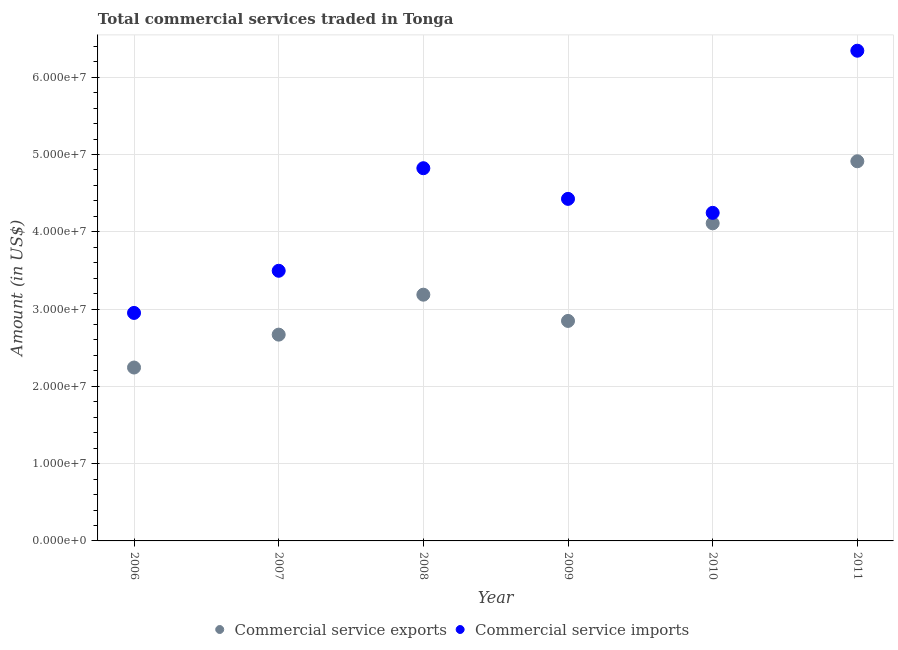How many different coloured dotlines are there?
Your answer should be compact. 2. Is the number of dotlines equal to the number of legend labels?
Ensure brevity in your answer.  Yes. What is the amount of commercial service exports in 2009?
Give a very brief answer. 2.85e+07. Across all years, what is the maximum amount of commercial service exports?
Keep it short and to the point. 4.91e+07. Across all years, what is the minimum amount of commercial service imports?
Your response must be concise. 2.95e+07. In which year was the amount of commercial service exports minimum?
Your answer should be compact. 2006. What is the total amount of commercial service exports in the graph?
Give a very brief answer. 2.00e+08. What is the difference between the amount of commercial service exports in 2009 and that in 2010?
Give a very brief answer. -1.26e+07. What is the difference between the amount of commercial service imports in 2011 and the amount of commercial service exports in 2007?
Offer a terse response. 3.67e+07. What is the average amount of commercial service imports per year?
Offer a terse response. 4.38e+07. In the year 2006, what is the difference between the amount of commercial service imports and amount of commercial service exports?
Provide a succinct answer. 7.06e+06. What is the ratio of the amount of commercial service exports in 2010 to that in 2011?
Ensure brevity in your answer.  0.84. Is the difference between the amount of commercial service imports in 2010 and 2011 greater than the difference between the amount of commercial service exports in 2010 and 2011?
Offer a very short reply. No. What is the difference between the highest and the second highest amount of commercial service exports?
Provide a short and direct response. 8.03e+06. What is the difference between the highest and the lowest amount of commercial service imports?
Your answer should be compact. 3.39e+07. Is the sum of the amount of commercial service imports in 2006 and 2007 greater than the maximum amount of commercial service exports across all years?
Offer a terse response. Yes. Is the amount of commercial service exports strictly less than the amount of commercial service imports over the years?
Make the answer very short. Yes. Are the values on the major ticks of Y-axis written in scientific E-notation?
Your answer should be very brief. Yes. What is the title of the graph?
Provide a short and direct response. Total commercial services traded in Tonga. Does "Arms exports" appear as one of the legend labels in the graph?
Ensure brevity in your answer.  No. What is the label or title of the X-axis?
Give a very brief answer. Year. What is the label or title of the Y-axis?
Make the answer very short. Amount (in US$). What is the Amount (in US$) in Commercial service exports in 2006?
Offer a very short reply. 2.24e+07. What is the Amount (in US$) of Commercial service imports in 2006?
Provide a short and direct response. 2.95e+07. What is the Amount (in US$) of Commercial service exports in 2007?
Your answer should be compact. 2.67e+07. What is the Amount (in US$) of Commercial service imports in 2007?
Provide a succinct answer. 3.50e+07. What is the Amount (in US$) of Commercial service exports in 2008?
Keep it short and to the point. 3.19e+07. What is the Amount (in US$) in Commercial service imports in 2008?
Keep it short and to the point. 4.82e+07. What is the Amount (in US$) in Commercial service exports in 2009?
Provide a short and direct response. 2.85e+07. What is the Amount (in US$) of Commercial service imports in 2009?
Your response must be concise. 4.43e+07. What is the Amount (in US$) in Commercial service exports in 2010?
Offer a terse response. 4.11e+07. What is the Amount (in US$) of Commercial service imports in 2010?
Your answer should be compact. 4.24e+07. What is the Amount (in US$) in Commercial service exports in 2011?
Ensure brevity in your answer.  4.91e+07. What is the Amount (in US$) in Commercial service imports in 2011?
Keep it short and to the point. 6.34e+07. Across all years, what is the maximum Amount (in US$) in Commercial service exports?
Your answer should be very brief. 4.91e+07. Across all years, what is the maximum Amount (in US$) of Commercial service imports?
Keep it short and to the point. 6.34e+07. Across all years, what is the minimum Amount (in US$) in Commercial service exports?
Your answer should be compact. 2.24e+07. Across all years, what is the minimum Amount (in US$) in Commercial service imports?
Provide a succinct answer. 2.95e+07. What is the total Amount (in US$) in Commercial service exports in the graph?
Offer a very short reply. 2.00e+08. What is the total Amount (in US$) in Commercial service imports in the graph?
Keep it short and to the point. 2.63e+08. What is the difference between the Amount (in US$) of Commercial service exports in 2006 and that in 2007?
Offer a very short reply. -4.26e+06. What is the difference between the Amount (in US$) in Commercial service imports in 2006 and that in 2007?
Your answer should be very brief. -5.45e+06. What is the difference between the Amount (in US$) in Commercial service exports in 2006 and that in 2008?
Offer a terse response. -9.42e+06. What is the difference between the Amount (in US$) in Commercial service imports in 2006 and that in 2008?
Offer a terse response. -1.87e+07. What is the difference between the Amount (in US$) of Commercial service exports in 2006 and that in 2009?
Offer a very short reply. -6.03e+06. What is the difference between the Amount (in US$) of Commercial service imports in 2006 and that in 2009?
Give a very brief answer. -1.48e+07. What is the difference between the Amount (in US$) in Commercial service exports in 2006 and that in 2010?
Make the answer very short. -1.87e+07. What is the difference between the Amount (in US$) of Commercial service imports in 2006 and that in 2010?
Your answer should be very brief. -1.29e+07. What is the difference between the Amount (in US$) of Commercial service exports in 2006 and that in 2011?
Provide a succinct answer. -2.67e+07. What is the difference between the Amount (in US$) of Commercial service imports in 2006 and that in 2011?
Ensure brevity in your answer.  -3.39e+07. What is the difference between the Amount (in US$) in Commercial service exports in 2007 and that in 2008?
Keep it short and to the point. -5.17e+06. What is the difference between the Amount (in US$) of Commercial service imports in 2007 and that in 2008?
Keep it short and to the point. -1.33e+07. What is the difference between the Amount (in US$) in Commercial service exports in 2007 and that in 2009?
Keep it short and to the point. -1.77e+06. What is the difference between the Amount (in US$) of Commercial service imports in 2007 and that in 2009?
Your answer should be very brief. -9.30e+06. What is the difference between the Amount (in US$) of Commercial service exports in 2007 and that in 2010?
Keep it short and to the point. -1.44e+07. What is the difference between the Amount (in US$) in Commercial service imports in 2007 and that in 2010?
Your answer should be very brief. -7.49e+06. What is the difference between the Amount (in US$) in Commercial service exports in 2007 and that in 2011?
Your answer should be very brief. -2.24e+07. What is the difference between the Amount (in US$) of Commercial service imports in 2007 and that in 2011?
Your answer should be very brief. -2.85e+07. What is the difference between the Amount (in US$) in Commercial service exports in 2008 and that in 2009?
Ensure brevity in your answer.  3.40e+06. What is the difference between the Amount (in US$) of Commercial service imports in 2008 and that in 2009?
Ensure brevity in your answer.  3.97e+06. What is the difference between the Amount (in US$) in Commercial service exports in 2008 and that in 2010?
Give a very brief answer. -9.24e+06. What is the difference between the Amount (in US$) of Commercial service imports in 2008 and that in 2010?
Ensure brevity in your answer.  5.78e+06. What is the difference between the Amount (in US$) of Commercial service exports in 2008 and that in 2011?
Make the answer very short. -1.73e+07. What is the difference between the Amount (in US$) of Commercial service imports in 2008 and that in 2011?
Offer a very short reply. -1.52e+07. What is the difference between the Amount (in US$) of Commercial service exports in 2009 and that in 2010?
Offer a very short reply. -1.26e+07. What is the difference between the Amount (in US$) of Commercial service imports in 2009 and that in 2010?
Keep it short and to the point. 1.81e+06. What is the difference between the Amount (in US$) of Commercial service exports in 2009 and that in 2011?
Ensure brevity in your answer.  -2.07e+07. What is the difference between the Amount (in US$) of Commercial service imports in 2009 and that in 2011?
Offer a very short reply. -1.92e+07. What is the difference between the Amount (in US$) in Commercial service exports in 2010 and that in 2011?
Make the answer very short. -8.03e+06. What is the difference between the Amount (in US$) in Commercial service imports in 2010 and that in 2011?
Give a very brief answer. -2.10e+07. What is the difference between the Amount (in US$) in Commercial service exports in 2006 and the Amount (in US$) in Commercial service imports in 2007?
Keep it short and to the point. -1.25e+07. What is the difference between the Amount (in US$) in Commercial service exports in 2006 and the Amount (in US$) in Commercial service imports in 2008?
Offer a terse response. -2.58e+07. What is the difference between the Amount (in US$) of Commercial service exports in 2006 and the Amount (in US$) of Commercial service imports in 2009?
Your answer should be compact. -2.18e+07. What is the difference between the Amount (in US$) of Commercial service exports in 2006 and the Amount (in US$) of Commercial service imports in 2010?
Give a very brief answer. -2.00e+07. What is the difference between the Amount (in US$) of Commercial service exports in 2006 and the Amount (in US$) of Commercial service imports in 2011?
Provide a succinct answer. -4.10e+07. What is the difference between the Amount (in US$) of Commercial service exports in 2007 and the Amount (in US$) of Commercial service imports in 2008?
Provide a succinct answer. -2.15e+07. What is the difference between the Amount (in US$) in Commercial service exports in 2007 and the Amount (in US$) in Commercial service imports in 2009?
Your answer should be compact. -1.76e+07. What is the difference between the Amount (in US$) of Commercial service exports in 2007 and the Amount (in US$) of Commercial service imports in 2010?
Provide a short and direct response. -1.58e+07. What is the difference between the Amount (in US$) of Commercial service exports in 2007 and the Amount (in US$) of Commercial service imports in 2011?
Ensure brevity in your answer.  -3.67e+07. What is the difference between the Amount (in US$) of Commercial service exports in 2008 and the Amount (in US$) of Commercial service imports in 2009?
Your answer should be compact. -1.24e+07. What is the difference between the Amount (in US$) of Commercial service exports in 2008 and the Amount (in US$) of Commercial service imports in 2010?
Offer a terse response. -1.06e+07. What is the difference between the Amount (in US$) of Commercial service exports in 2008 and the Amount (in US$) of Commercial service imports in 2011?
Make the answer very short. -3.16e+07. What is the difference between the Amount (in US$) in Commercial service exports in 2009 and the Amount (in US$) in Commercial service imports in 2010?
Offer a terse response. -1.40e+07. What is the difference between the Amount (in US$) of Commercial service exports in 2009 and the Amount (in US$) of Commercial service imports in 2011?
Offer a terse response. -3.50e+07. What is the difference between the Amount (in US$) in Commercial service exports in 2010 and the Amount (in US$) in Commercial service imports in 2011?
Provide a succinct answer. -2.23e+07. What is the average Amount (in US$) in Commercial service exports per year?
Your answer should be compact. 3.33e+07. What is the average Amount (in US$) in Commercial service imports per year?
Give a very brief answer. 4.38e+07. In the year 2006, what is the difference between the Amount (in US$) of Commercial service exports and Amount (in US$) of Commercial service imports?
Offer a very short reply. -7.06e+06. In the year 2007, what is the difference between the Amount (in US$) of Commercial service exports and Amount (in US$) of Commercial service imports?
Keep it short and to the point. -8.26e+06. In the year 2008, what is the difference between the Amount (in US$) in Commercial service exports and Amount (in US$) in Commercial service imports?
Ensure brevity in your answer.  -1.64e+07. In the year 2009, what is the difference between the Amount (in US$) in Commercial service exports and Amount (in US$) in Commercial service imports?
Offer a terse response. -1.58e+07. In the year 2010, what is the difference between the Amount (in US$) of Commercial service exports and Amount (in US$) of Commercial service imports?
Your answer should be compact. -1.35e+06. In the year 2011, what is the difference between the Amount (in US$) of Commercial service exports and Amount (in US$) of Commercial service imports?
Your answer should be very brief. -1.43e+07. What is the ratio of the Amount (in US$) in Commercial service exports in 2006 to that in 2007?
Your answer should be very brief. 0.84. What is the ratio of the Amount (in US$) in Commercial service imports in 2006 to that in 2007?
Provide a succinct answer. 0.84. What is the ratio of the Amount (in US$) of Commercial service exports in 2006 to that in 2008?
Your answer should be very brief. 0.7. What is the ratio of the Amount (in US$) in Commercial service imports in 2006 to that in 2008?
Ensure brevity in your answer.  0.61. What is the ratio of the Amount (in US$) in Commercial service exports in 2006 to that in 2009?
Your answer should be compact. 0.79. What is the ratio of the Amount (in US$) in Commercial service imports in 2006 to that in 2009?
Offer a terse response. 0.67. What is the ratio of the Amount (in US$) in Commercial service exports in 2006 to that in 2010?
Provide a succinct answer. 0.55. What is the ratio of the Amount (in US$) of Commercial service imports in 2006 to that in 2010?
Your answer should be very brief. 0.69. What is the ratio of the Amount (in US$) in Commercial service exports in 2006 to that in 2011?
Offer a terse response. 0.46. What is the ratio of the Amount (in US$) in Commercial service imports in 2006 to that in 2011?
Give a very brief answer. 0.47. What is the ratio of the Amount (in US$) of Commercial service exports in 2007 to that in 2008?
Offer a very short reply. 0.84. What is the ratio of the Amount (in US$) of Commercial service imports in 2007 to that in 2008?
Provide a succinct answer. 0.72. What is the ratio of the Amount (in US$) of Commercial service exports in 2007 to that in 2009?
Your response must be concise. 0.94. What is the ratio of the Amount (in US$) in Commercial service imports in 2007 to that in 2009?
Provide a short and direct response. 0.79. What is the ratio of the Amount (in US$) of Commercial service exports in 2007 to that in 2010?
Offer a terse response. 0.65. What is the ratio of the Amount (in US$) of Commercial service imports in 2007 to that in 2010?
Keep it short and to the point. 0.82. What is the ratio of the Amount (in US$) of Commercial service exports in 2007 to that in 2011?
Offer a terse response. 0.54. What is the ratio of the Amount (in US$) in Commercial service imports in 2007 to that in 2011?
Offer a terse response. 0.55. What is the ratio of the Amount (in US$) of Commercial service exports in 2008 to that in 2009?
Keep it short and to the point. 1.12. What is the ratio of the Amount (in US$) in Commercial service imports in 2008 to that in 2009?
Give a very brief answer. 1.09. What is the ratio of the Amount (in US$) of Commercial service exports in 2008 to that in 2010?
Offer a terse response. 0.78. What is the ratio of the Amount (in US$) in Commercial service imports in 2008 to that in 2010?
Offer a terse response. 1.14. What is the ratio of the Amount (in US$) in Commercial service exports in 2008 to that in 2011?
Offer a terse response. 0.65. What is the ratio of the Amount (in US$) of Commercial service imports in 2008 to that in 2011?
Your answer should be very brief. 0.76. What is the ratio of the Amount (in US$) in Commercial service exports in 2009 to that in 2010?
Give a very brief answer. 0.69. What is the ratio of the Amount (in US$) of Commercial service imports in 2009 to that in 2010?
Give a very brief answer. 1.04. What is the ratio of the Amount (in US$) in Commercial service exports in 2009 to that in 2011?
Your answer should be compact. 0.58. What is the ratio of the Amount (in US$) in Commercial service imports in 2009 to that in 2011?
Provide a succinct answer. 0.7. What is the ratio of the Amount (in US$) in Commercial service exports in 2010 to that in 2011?
Ensure brevity in your answer.  0.84. What is the ratio of the Amount (in US$) in Commercial service imports in 2010 to that in 2011?
Your answer should be compact. 0.67. What is the difference between the highest and the second highest Amount (in US$) of Commercial service exports?
Offer a terse response. 8.03e+06. What is the difference between the highest and the second highest Amount (in US$) in Commercial service imports?
Provide a short and direct response. 1.52e+07. What is the difference between the highest and the lowest Amount (in US$) of Commercial service exports?
Offer a very short reply. 2.67e+07. What is the difference between the highest and the lowest Amount (in US$) in Commercial service imports?
Provide a succinct answer. 3.39e+07. 